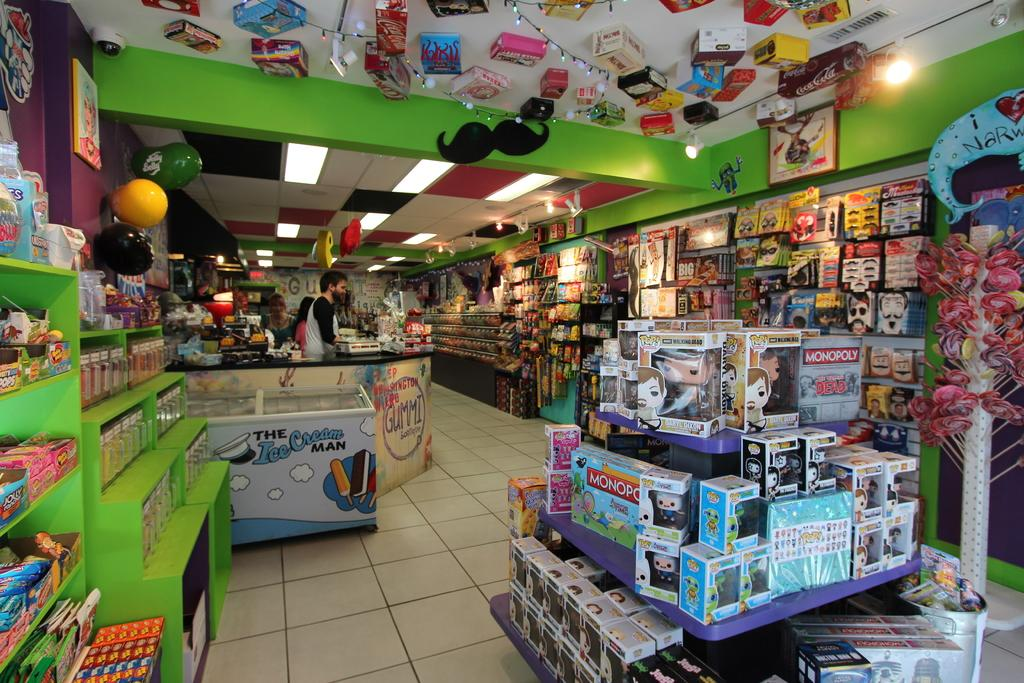<image>
Present a compact description of the photo's key features. A toy store has Monopoly games on display. 